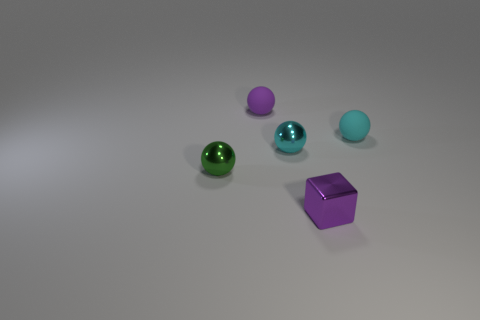Are there any other things that are made of the same material as the small purple block?
Give a very brief answer. Yes. There is a tiny object that is the same color as the tiny shiny block; what is its shape?
Provide a short and direct response. Sphere. Does the shiny cube that is right of the purple rubber object have the same size as the tiny green ball?
Your answer should be compact. Yes. Are there any spheres of the same color as the small metallic cube?
Offer a very short reply. Yes. What is the size of the cyan object that is the same material as the small block?
Give a very brief answer. Small. Is the number of spheres that are behind the purple metal block greater than the number of small shiny blocks behind the small cyan rubber object?
Keep it short and to the point. Yes. How many other things are the same material as the purple sphere?
Your response must be concise. 1. Do the purple object that is behind the tiny green object and the purple cube have the same material?
Offer a very short reply. No. What shape is the cyan rubber object?
Keep it short and to the point. Sphere. Is the number of small cyan balls that are to the left of the purple rubber ball greater than the number of small green metal objects?
Keep it short and to the point. No. 